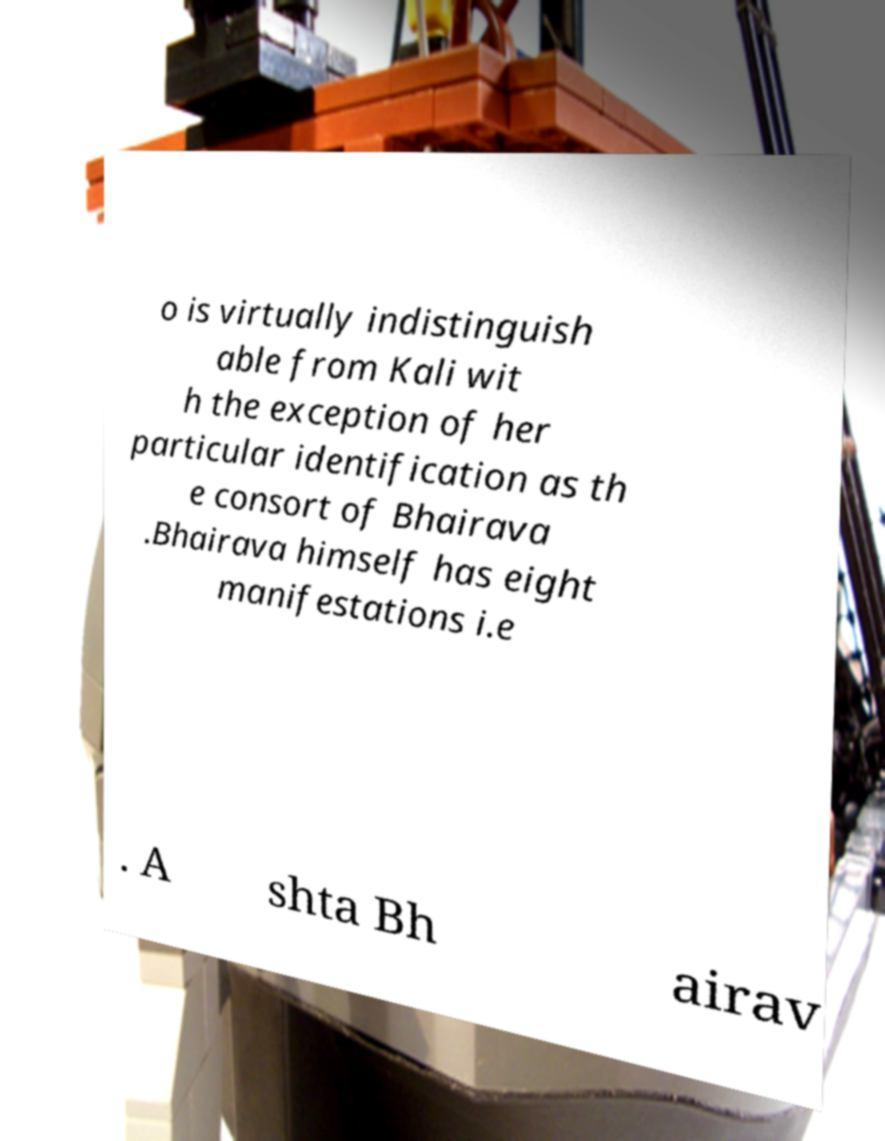There's text embedded in this image that I need extracted. Can you transcribe it verbatim? o is virtually indistinguish able from Kali wit h the exception of her particular identification as th e consort of Bhairava .Bhairava himself has eight manifestations i.e . A shta Bh airav 